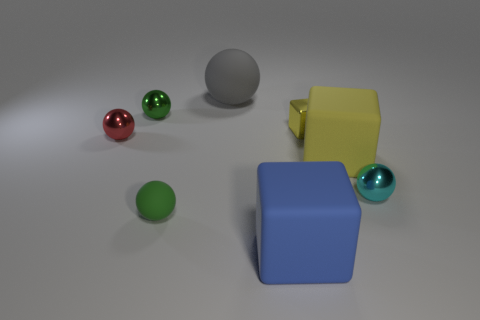Subtract all large blocks. How many blocks are left? 1 Add 4 tiny cyan objects. How many tiny cyan objects are left? 5 Add 2 big blocks. How many big blocks exist? 4 Add 2 small yellow things. How many objects exist? 10 Subtract all blue cubes. How many cubes are left? 2 Subtract 0 red cylinders. How many objects are left? 8 Subtract all cubes. How many objects are left? 5 Subtract 2 blocks. How many blocks are left? 1 Subtract all green balls. Subtract all gray cylinders. How many balls are left? 3 Subtract all green balls. How many yellow cubes are left? 2 